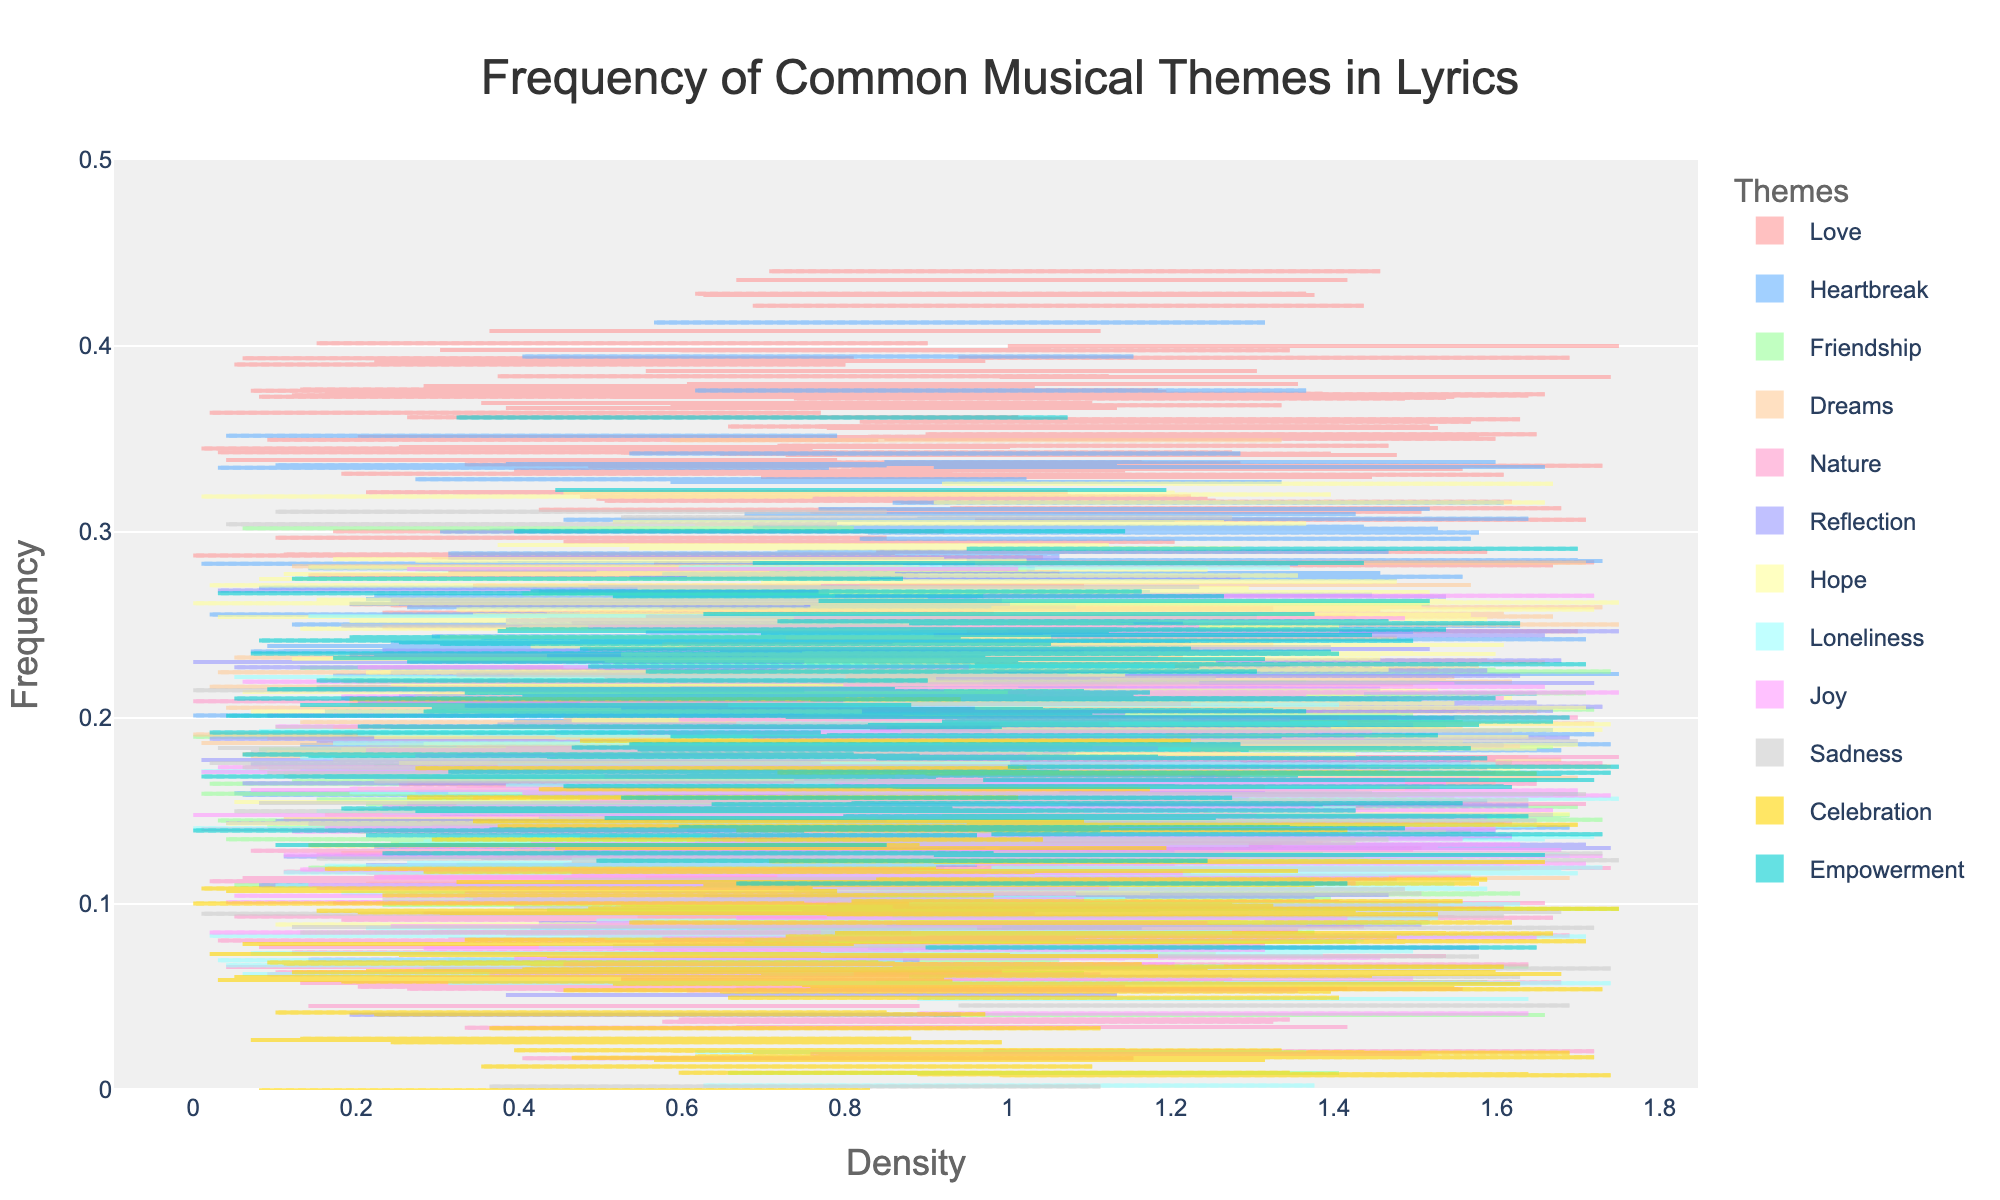What is the title of the density plot? The title of the plot is displayed at the top and reads 'Frequency of Common Musical Themes in Lyrics'.
Answer: Frequency of Common Musical Themes in Lyrics Which theme has the highest frequency in the plot? By observing the density plot, the theme 'Love' has the highest frequency with a value of 0.35.
Answer: Love How does the frequency of the theme 'Dreams' compare to 'Hope'? Looking at the density plot, 'Dreams' has a frequency of 0.2, while 'Hope' has a frequency of 0.22. Therefore, 'Hope' has a slightly higher frequency than 'Dreams'.
Answer: Hope has a higher frequency than Dreams Which color is used to represent the 'Sadness' theme? The color representing 'Sadness' on the density plot can be identified as grey or a shade close to it.
Answer: grey How many themes have a frequency higher than 0.2? By counting the densities, the themes 'Love', 'Heartbreak', 'Hope', and 'Empowerment' have frequencies higher than 0.2.
Answer: Four themes What is the least frequent theme indicated in the plot? The theme 'Celebration' has the lowest frequency, visible at 0.08.
Answer: Celebration Compare the frequencies of 'Friendship' and 'Loneliness'. 'Friendship' has a frequency of 0.15, whereas 'Loneliness' has a frequency of 0.12. 'Friendship' has a higher frequency than 'Loneliness'.
Answer: Friendship has a higher frequency than Loneliness What range does the y-axis cover in the density plot? The y-axis of the density plot ranges from 0.0 to 0.5, as indicated by the axis limits.
Answer: 0.0 to 0.5 